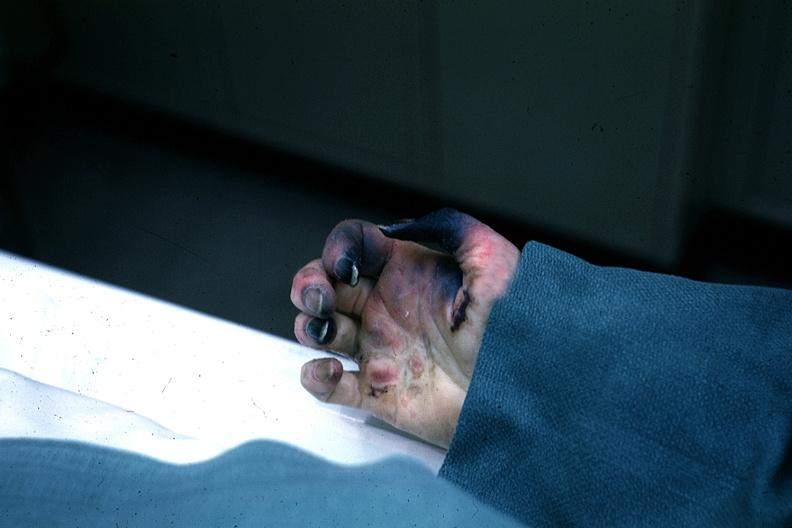re extremities present?
Answer the question using a single word or phrase. Yes 